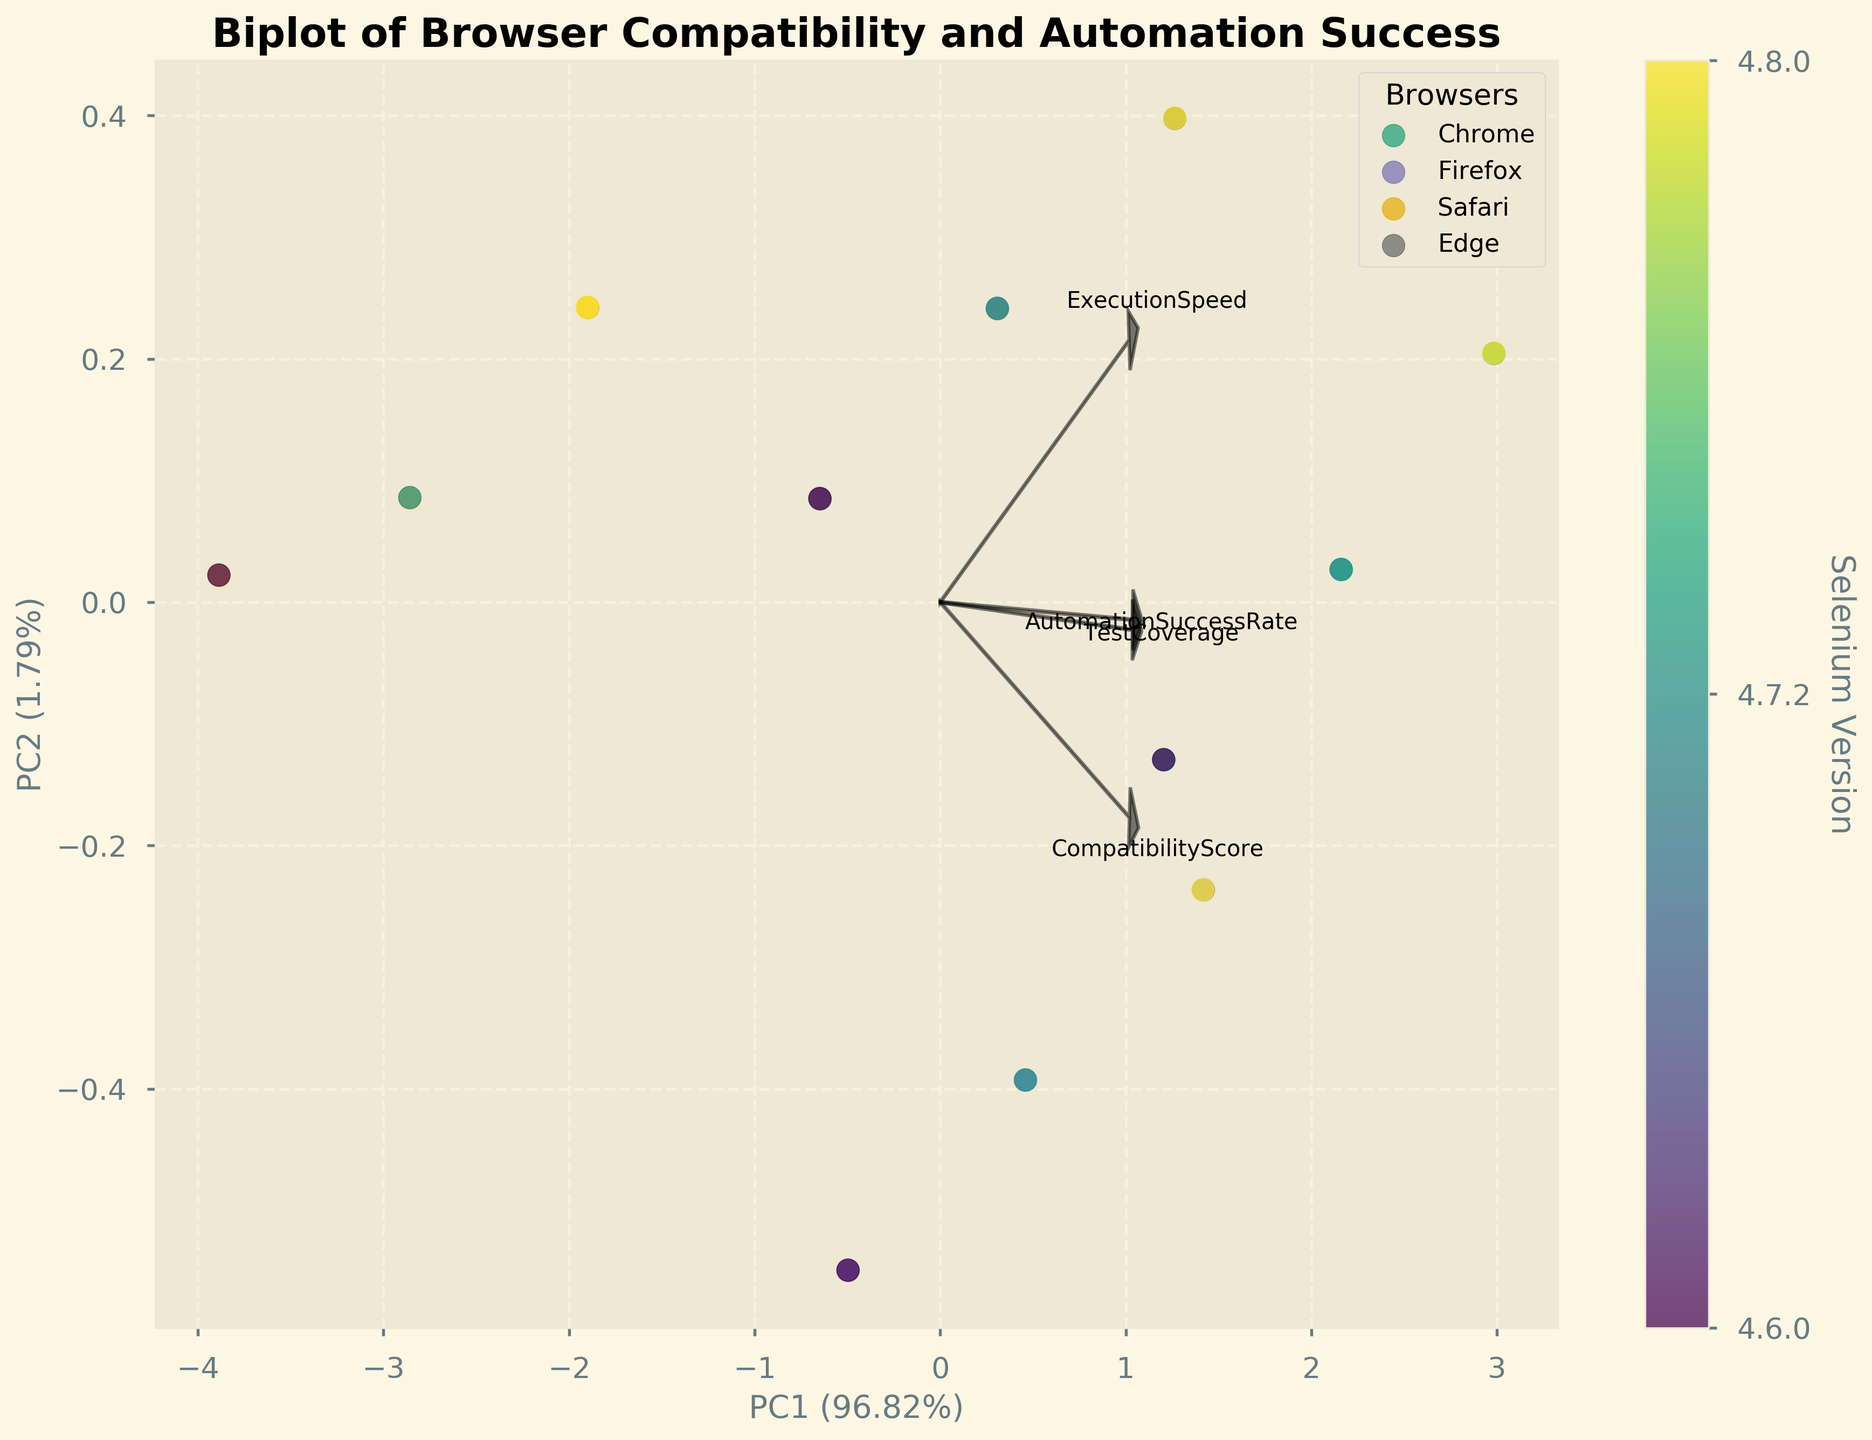What is the title of the biplot? The title of the plot is generally located at the top of the figure. It describes the purpose or content of the plot.
Answer: Biplot of Browser Compatibility and Automation Success What are the axes labeled as? The labels on the axes are typically at the edges of the plot and describe the primary components derived from PCA.
Answer: PC1 and PC2 Which browser has the highest Automation Success Rate according to the biplot? To determine this, look for the points corresponding to each browser and note the orientation of the 'AutomationSuccessRate' loading vector. The browser located farthest along this direction has the highest rate.
Answer: Chrome Which Selenium version appears to have the highest overall compatibility across browsers? Examine the color bar that denotes Selenium versions and identify which color is associated with the highest compatibility scores spread across multiple browser points.
Answer: 4.8.0 How do 'TestCoverage' and 'ExecutionSpeed' compare across browsers? Observe the direction and magnitude of the loading vectors for 'TestCoverage' and 'ExecutionSpeed'. Check which browser points align closely along these vectors to understand their relative performance on these metrics.
Answer: TestCoverage and ExecutionSpeed are highest for Chrome across all versions Which feature has the least impact on the first principal component (PC1)? Look at the loading vectors' projections onto the PC1 axis and identify the feature whose vector is closest to zero along this axis.
Answer: AutomationSuccessRate Are Chrome and Safari closer together or further apart in terms of compatibility and automation success? Evaluate the relative positions of the Chrome and Safari points in the PCA space. The Euclidean distance between these points will indicate their proximity.
Answer: Further apart What percentage of variation is explained by the first principal component (PC1)? The x-axis label will have a percentage value indicating the variance explained by the first principal component.
Answer: Approximately 52% Which browser shows the most variation across different Selenium versions? Identify the browser cluster that has the widest spread of points representing different Selenium versions.
Answer: Chrome How does the Selenium version 4.6.0 performance of Edge compare with version 4.8.0 in terms of Automation Success Rate? Compare the points corresponding to Edge for Selenium versions 4.6.0 and 4.8.0 along the direction of the 'AutomationSuccessRate' loading vector.
Answer: Slightly lower for 4.6.0 